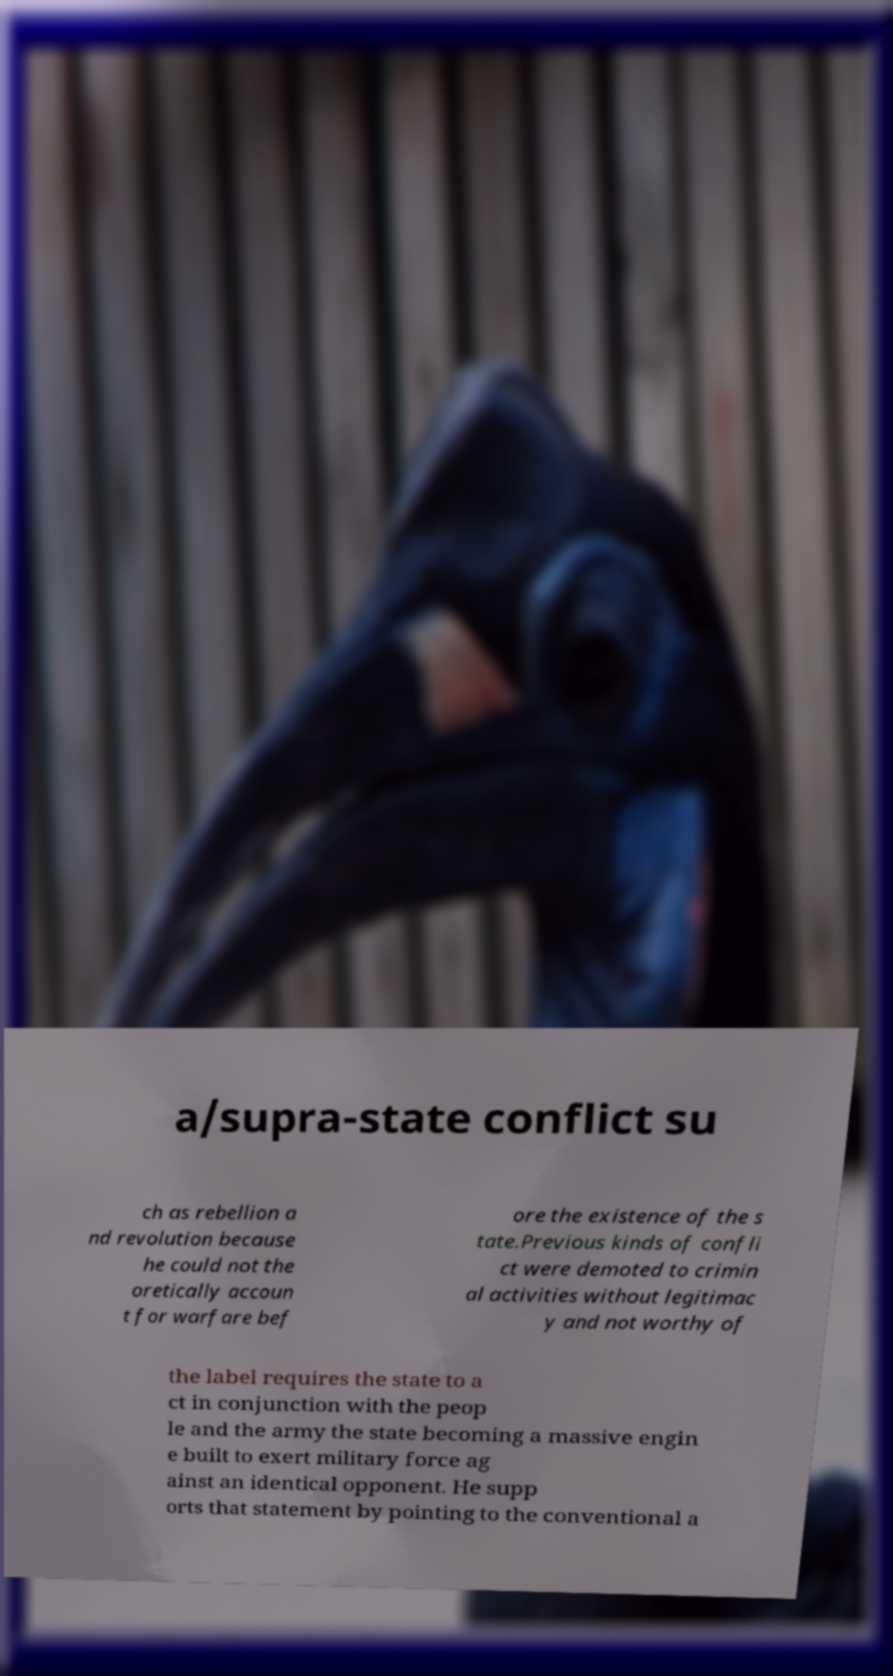Can you read and provide the text displayed in the image?This photo seems to have some interesting text. Can you extract and type it out for me? a/supra-state conflict su ch as rebellion a nd revolution because he could not the oretically accoun t for warfare bef ore the existence of the s tate.Previous kinds of confli ct were demoted to crimin al activities without legitimac y and not worthy of the label requires the state to a ct in conjunction with the peop le and the army the state becoming a massive engin e built to exert military force ag ainst an identical opponent. He supp orts that statement by pointing to the conventional a 